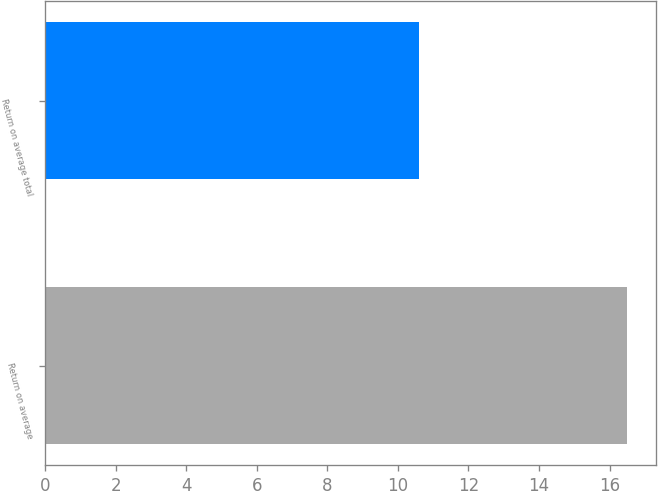<chart> <loc_0><loc_0><loc_500><loc_500><bar_chart><fcel>Return on average<fcel>Return on average total<nl><fcel>16.5<fcel>10.6<nl></chart> 